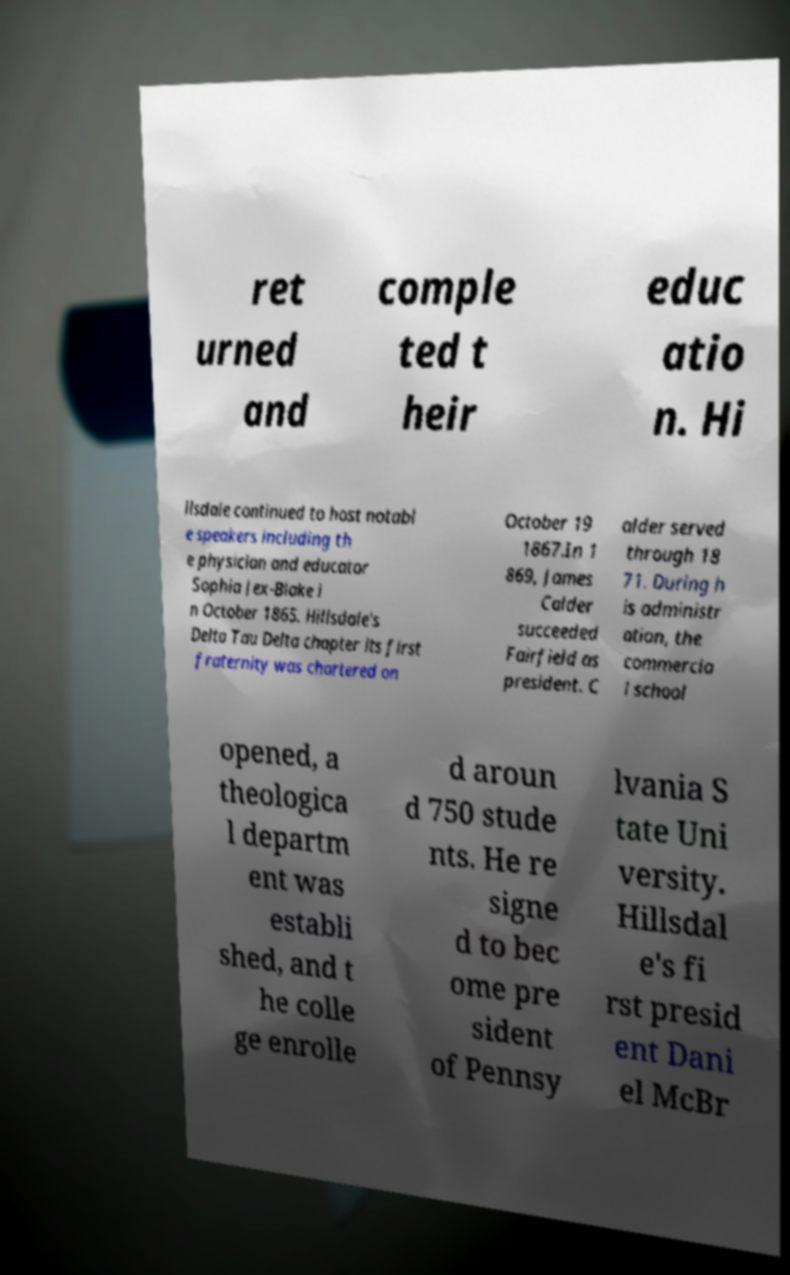Could you assist in decoding the text presented in this image and type it out clearly? ret urned and comple ted t heir educ atio n. Hi llsdale continued to host notabl e speakers including th e physician and educator Sophia Jex-Blake i n October 1865. Hillsdale's Delta Tau Delta chapter its first fraternity was chartered on October 19 1867.In 1 869, James Calder succeeded Fairfield as president. C alder served through 18 71. During h is administr ation, the commercia l school opened, a theologica l departm ent was establi shed, and t he colle ge enrolle d aroun d 750 stude nts. He re signe d to bec ome pre sident of Pennsy lvania S tate Uni versity. Hillsdal e's fi rst presid ent Dani el McBr 